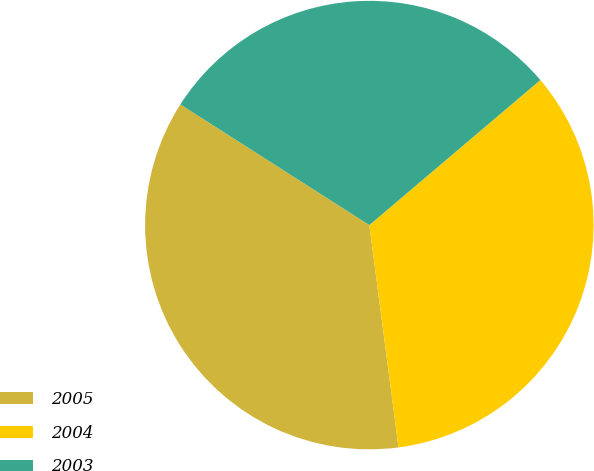<chart> <loc_0><loc_0><loc_500><loc_500><pie_chart><fcel>2005<fcel>2004<fcel>2003<nl><fcel>36.12%<fcel>34.12%<fcel>29.76%<nl></chart> 